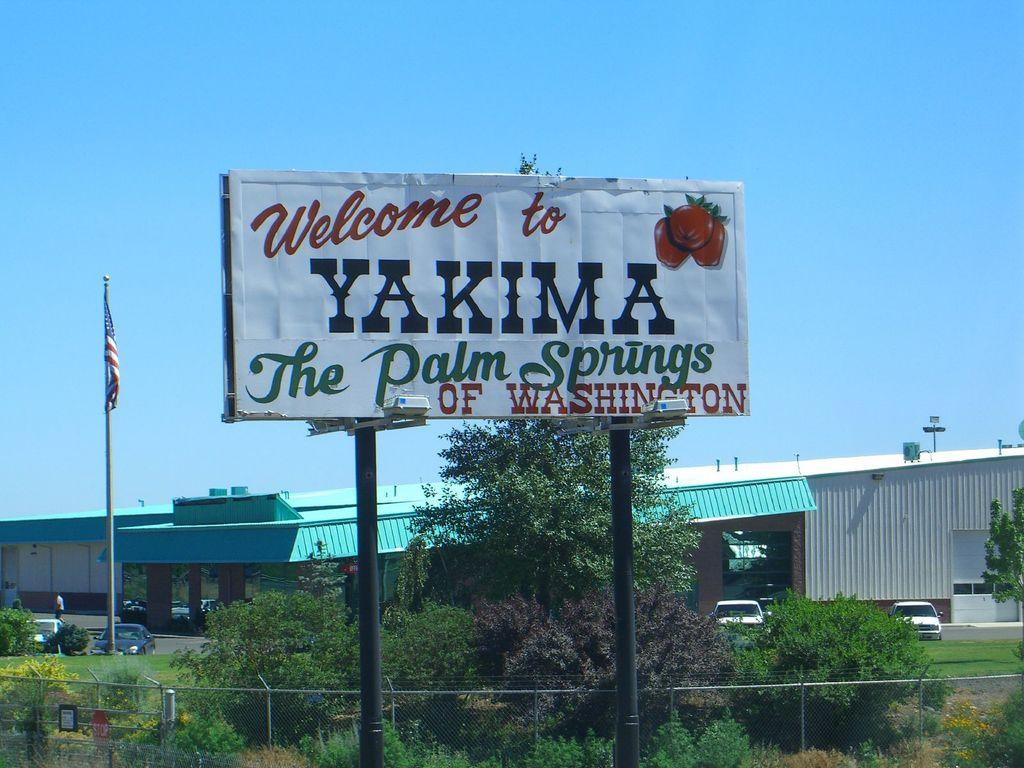Provide a one-sentence caption for the provided image. A large sign by the roadise that welcomes us to Yakima, the Palm Springs of Washington. 